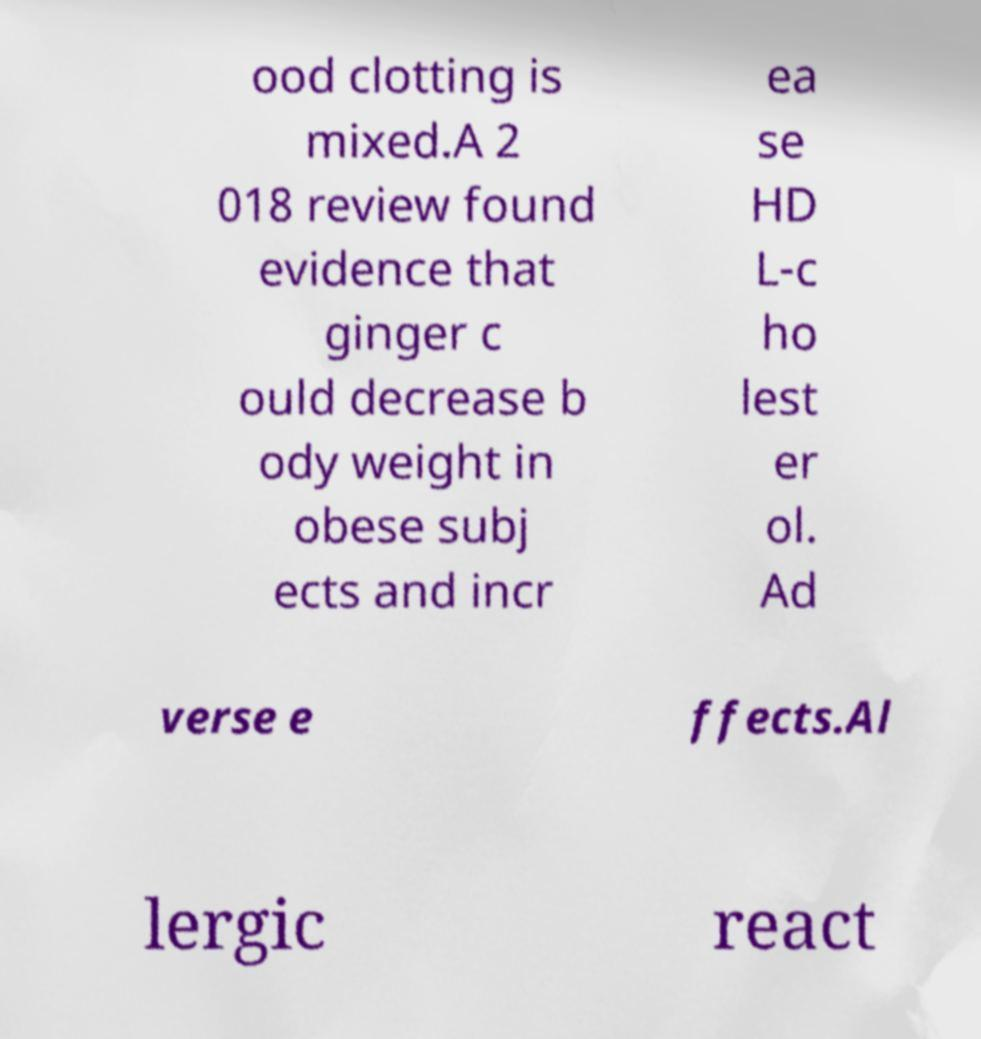For documentation purposes, I need the text within this image transcribed. Could you provide that? ood clotting is mixed.A 2 018 review found evidence that ginger c ould decrease b ody weight in obese subj ects and incr ea se HD L-c ho lest er ol. Ad verse e ffects.Al lergic react 